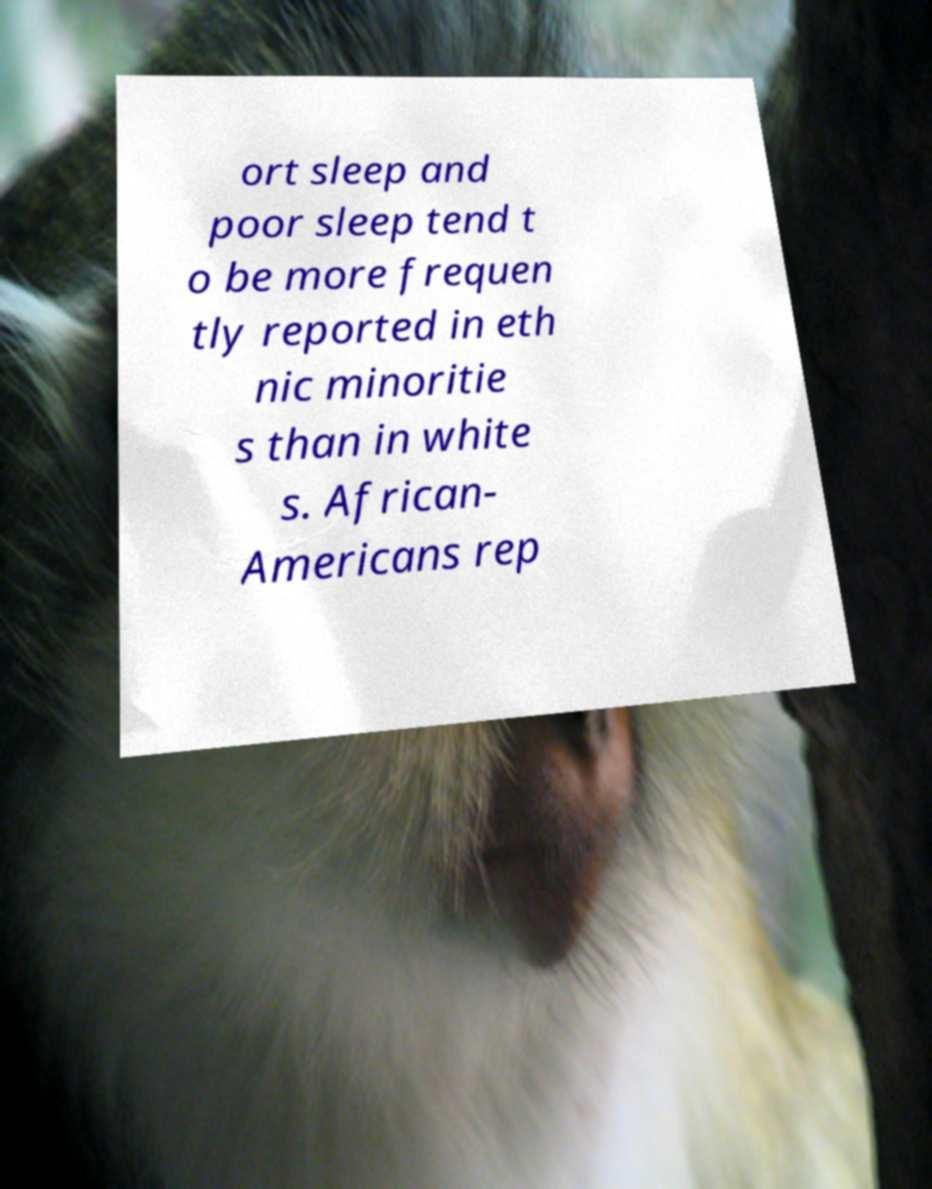Please read and relay the text visible in this image. What does it say? ort sleep and poor sleep tend t o be more frequen tly reported in eth nic minoritie s than in white s. African- Americans rep 